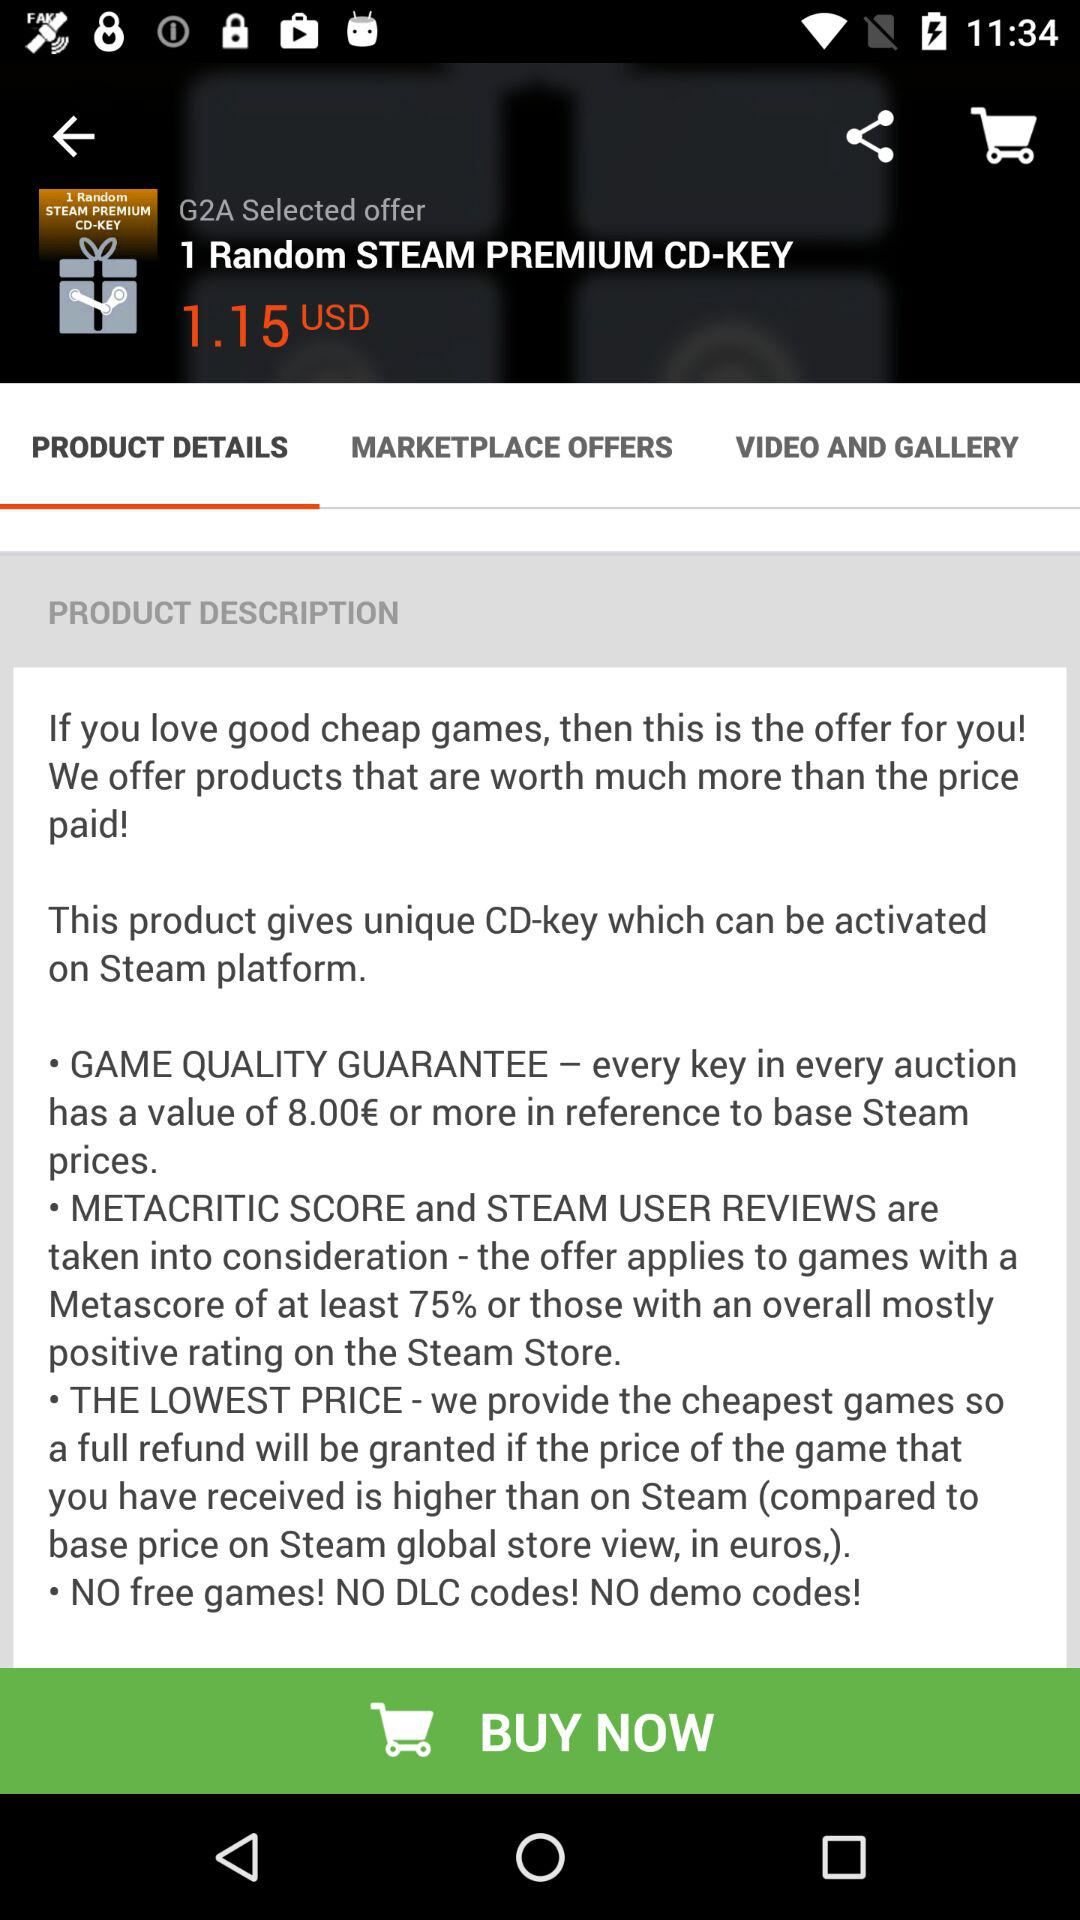What's the price of "1 Random STEAM PREMIUM CD-KEY"? The price is 1.15 USD. 